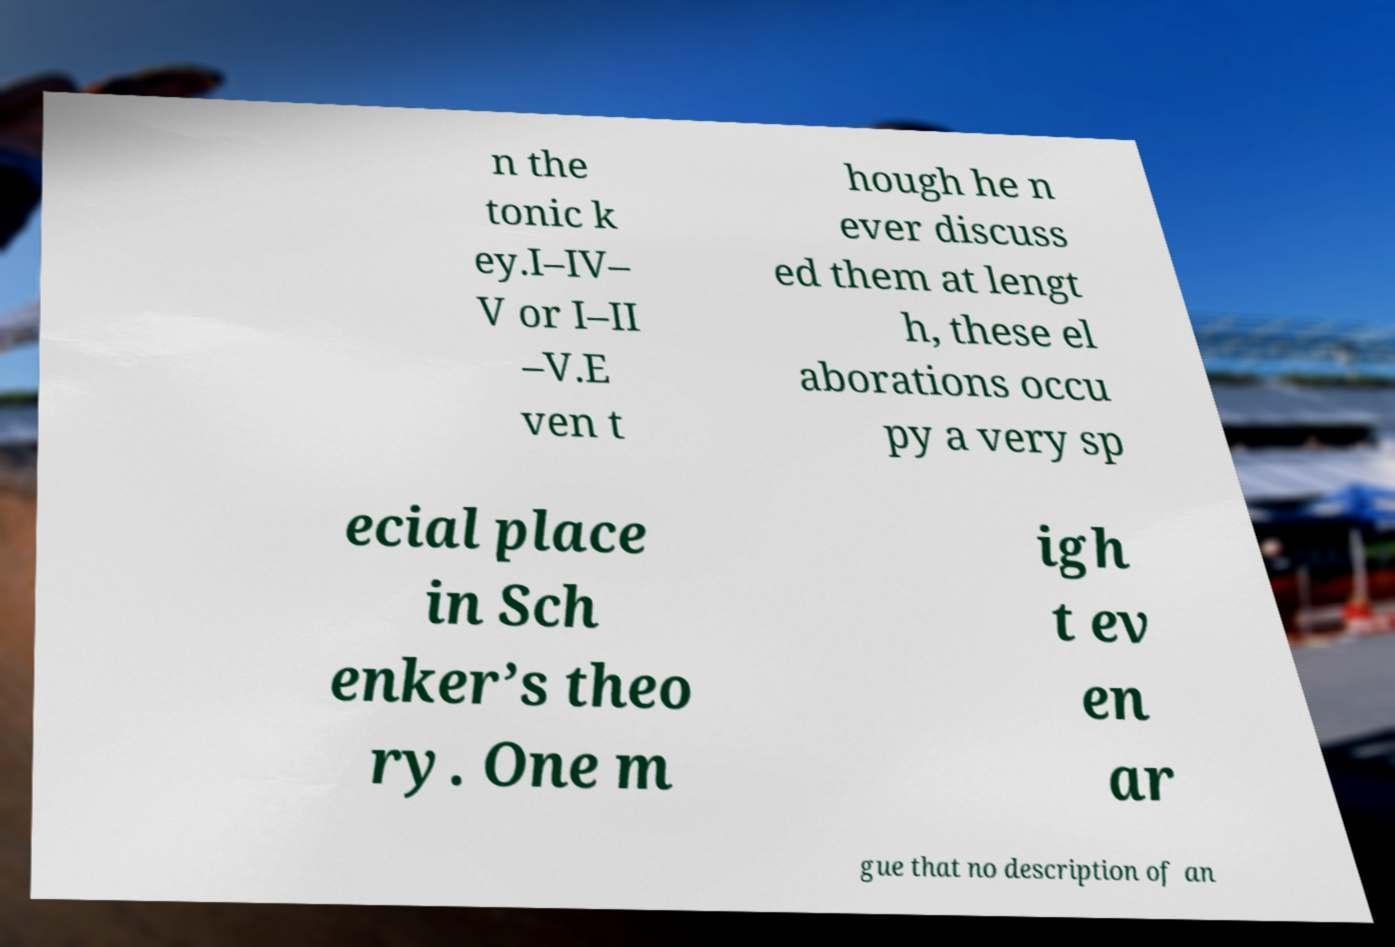Can you accurately transcribe the text from the provided image for me? n the tonic k ey.I–IV– V or I–II –V.E ven t hough he n ever discuss ed them at lengt h, these el aborations occu py a very sp ecial place in Sch enker’s theo ry. One m igh t ev en ar gue that no description of an 